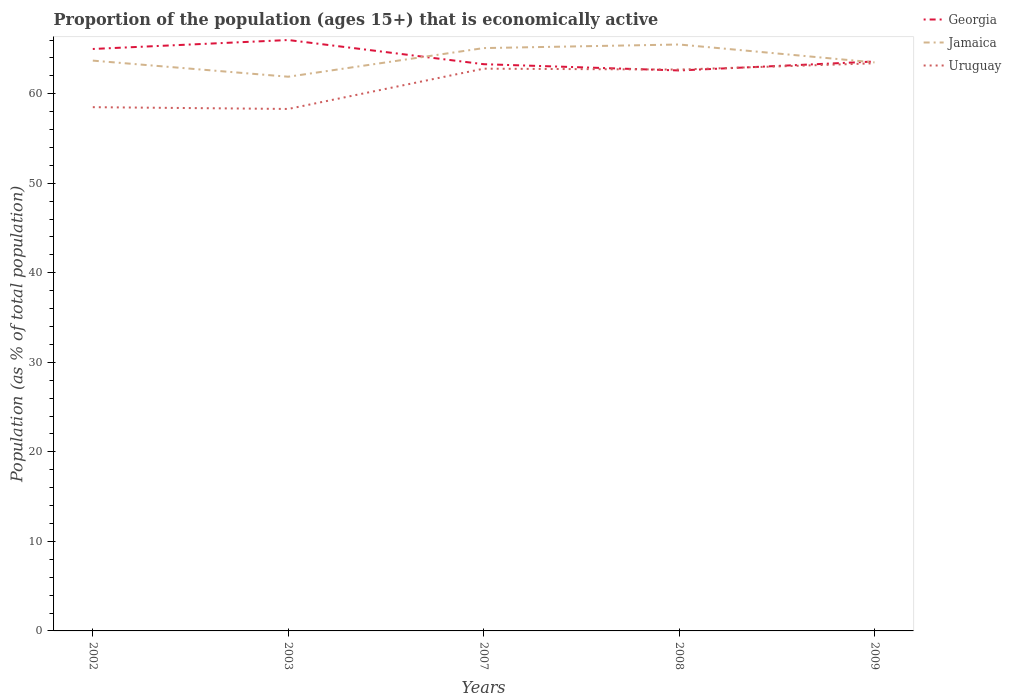Is the number of lines equal to the number of legend labels?
Ensure brevity in your answer.  Yes. Across all years, what is the maximum proportion of the population that is economically active in Uruguay?
Offer a very short reply. 58.3. What is the total proportion of the population that is economically active in Jamaica in the graph?
Provide a short and direct response. 1.6. What is the difference between the highest and the second highest proportion of the population that is economically active in Georgia?
Offer a very short reply. 3.4. What is the difference between the highest and the lowest proportion of the population that is economically active in Jamaica?
Give a very brief answer. 2. How many lines are there?
Offer a very short reply. 3. What is the difference between two consecutive major ticks on the Y-axis?
Offer a terse response. 10. Does the graph contain any zero values?
Ensure brevity in your answer.  No. Does the graph contain grids?
Keep it short and to the point. No. Where does the legend appear in the graph?
Your answer should be very brief. Top right. How are the legend labels stacked?
Give a very brief answer. Vertical. What is the title of the graph?
Offer a very short reply. Proportion of the population (ages 15+) that is economically active. Does "Greenland" appear as one of the legend labels in the graph?
Offer a terse response. No. What is the label or title of the Y-axis?
Your answer should be compact. Population (as % of total population). What is the Population (as % of total population) of Georgia in 2002?
Your answer should be very brief. 65. What is the Population (as % of total population) in Jamaica in 2002?
Your answer should be very brief. 63.7. What is the Population (as % of total population) in Uruguay in 2002?
Give a very brief answer. 58.5. What is the Population (as % of total population) in Georgia in 2003?
Keep it short and to the point. 66. What is the Population (as % of total population) in Jamaica in 2003?
Your answer should be compact. 61.9. What is the Population (as % of total population) of Uruguay in 2003?
Your response must be concise. 58.3. What is the Population (as % of total population) in Georgia in 2007?
Make the answer very short. 63.3. What is the Population (as % of total population) in Jamaica in 2007?
Offer a very short reply. 65.1. What is the Population (as % of total population) in Uruguay in 2007?
Keep it short and to the point. 62.8. What is the Population (as % of total population) of Georgia in 2008?
Provide a succinct answer. 62.6. What is the Population (as % of total population) in Jamaica in 2008?
Provide a succinct answer. 65.5. What is the Population (as % of total population) in Uruguay in 2008?
Ensure brevity in your answer.  62.7. What is the Population (as % of total population) of Georgia in 2009?
Ensure brevity in your answer.  63.6. What is the Population (as % of total population) of Jamaica in 2009?
Ensure brevity in your answer.  63.5. What is the Population (as % of total population) in Uruguay in 2009?
Keep it short and to the point. 63.4. Across all years, what is the maximum Population (as % of total population) in Georgia?
Keep it short and to the point. 66. Across all years, what is the maximum Population (as % of total population) of Jamaica?
Your response must be concise. 65.5. Across all years, what is the maximum Population (as % of total population) of Uruguay?
Give a very brief answer. 63.4. Across all years, what is the minimum Population (as % of total population) in Georgia?
Provide a short and direct response. 62.6. Across all years, what is the minimum Population (as % of total population) in Jamaica?
Provide a short and direct response. 61.9. Across all years, what is the minimum Population (as % of total population) in Uruguay?
Offer a very short reply. 58.3. What is the total Population (as % of total population) of Georgia in the graph?
Offer a very short reply. 320.5. What is the total Population (as % of total population) of Jamaica in the graph?
Ensure brevity in your answer.  319.7. What is the total Population (as % of total population) in Uruguay in the graph?
Give a very brief answer. 305.7. What is the difference between the Population (as % of total population) of Jamaica in 2002 and that in 2007?
Provide a succinct answer. -1.4. What is the difference between the Population (as % of total population) of Uruguay in 2002 and that in 2008?
Provide a short and direct response. -4.2. What is the difference between the Population (as % of total population) in Georgia in 2002 and that in 2009?
Provide a succinct answer. 1.4. What is the difference between the Population (as % of total population) of Jamaica in 2002 and that in 2009?
Your answer should be compact. 0.2. What is the difference between the Population (as % of total population) in Jamaica in 2003 and that in 2007?
Offer a very short reply. -3.2. What is the difference between the Population (as % of total population) in Uruguay in 2003 and that in 2007?
Make the answer very short. -4.5. What is the difference between the Population (as % of total population) in Jamaica in 2003 and that in 2008?
Make the answer very short. -3.6. What is the difference between the Population (as % of total population) of Uruguay in 2003 and that in 2008?
Offer a very short reply. -4.4. What is the difference between the Population (as % of total population) in Jamaica in 2003 and that in 2009?
Make the answer very short. -1.6. What is the difference between the Population (as % of total population) in Georgia in 2007 and that in 2008?
Your answer should be compact. 0.7. What is the difference between the Population (as % of total population) in Uruguay in 2007 and that in 2008?
Offer a terse response. 0.1. What is the difference between the Population (as % of total population) of Georgia in 2007 and that in 2009?
Offer a very short reply. -0.3. What is the difference between the Population (as % of total population) in Jamaica in 2007 and that in 2009?
Provide a succinct answer. 1.6. What is the difference between the Population (as % of total population) in Uruguay in 2007 and that in 2009?
Your answer should be compact. -0.6. What is the difference between the Population (as % of total population) in Georgia in 2008 and that in 2009?
Keep it short and to the point. -1. What is the difference between the Population (as % of total population) in Jamaica in 2008 and that in 2009?
Offer a terse response. 2. What is the difference between the Population (as % of total population) in Uruguay in 2008 and that in 2009?
Keep it short and to the point. -0.7. What is the difference between the Population (as % of total population) in Georgia in 2002 and the Population (as % of total population) in Jamaica in 2007?
Your response must be concise. -0.1. What is the difference between the Population (as % of total population) in Georgia in 2002 and the Population (as % of total population) in Uruguay in 2007?
Keep it short and to the point. 2.2. What is the difference between the Population (as % of total population) in Jamaica in 2002 and the Population (as % of total population) in Uruguay in 2007?
Give a very brief answer. 0.9. What is the difference between the Population (as % of total population) of Georgia in 2002 and the Population (as % of total population) of Jamaica in 2008?
Make the answer very short. -0.5. What is the difference between the Population (as % of total population) in Jamaica in 2002 and the Population (as % of total population) in Uruguay in 2008?
Give a very brief answer. 1. What is the difference between the Population (as % of total population) of Jamaica in 2002 and the Population (as % of total population) of Uruguay in 2009?
Offer a terse response. 0.3. What is the difference between the Population (as % of total population) in Georgia in 2003 and the Population (as % of total population) in Jamaica in 2008?
Make the answer very short. 0.5. What is the difference between the Population (as % of total population) in Georgia in 2007 and the Population (as % of total population) in Jamaica in 2008?
Provide a short and direct response. -2.2. What is the difference between the Population (as % of total population) in Jamaica in 2007 and the Population (as % of total population) in Uruguay in 2008?
Your answer should be very brief. 2.4. What is the difference between the Population (as % of total population) in Georgia in 2007 and the Population (as % of total population) in Jamaica in 2009?
Provide a short and direct response. -0.2. What is the difference between the Population (as % of total population) of Georgia in 2007 and the Population (as % of total population) of Uruguay in 2009?
Ensure brevity in your answer.  -0.1. What is the difference between the Population (as % of total population) of Jamaica in 2007 and the Population (as % of total population) of Uruguay in 2009?
Offer a terse response. 1.7. What is the difference between the Population (as % of total population) of Georgia in 2008 and the Population (as % of total population) of Jamaica in 2009?
Your response must be concise. -0.9. What is the difference between the Population (as % of total population) of Georgia in 2008 and the Population (as % of total population) of Uruguay in 2009?
Make the answer very short. -0.8. What is the difference between the Population (as % of total population) in Jamaica in 2008 and the Population (as % of total population) in Uruguay in 2009?
Your response must be concise. 2.1. What is the average Population (as % of total population) in Georgia per year?
Ensure brevity in your answer.  64.1. What is the average Population (as % of total population) of Jamaica per year?
Ensure brevity in your answer.  63.94. What is the average Population (as % of total population) in Uruguay per year?
Your response must be concise. 61.14. In the year 2003, what is the difference between the Population (as % of total population) in Georgia and Population (as % of total population) in Uruguay?
Keep it short and to the point. 7.7. In the year 2007, what is the difference between the Population (as % of total population) in Georgia and Population (as % of total population) in Uruguay?
Your answer should be very brief. 0.5. In the year 2008, what is the difference between the Population (as % of total population) of Georgia and Population (as % of total population) of Uruguay?
Ensure brevity in your answer.  -0.1. In the year 2009, what is the difference between the Population (as % of total population) of Georgia and Population (as % of total population) of Jamaica?
Your response must be concise. 0.1. In the year 2009, what is the difference between the Population (as % of total population) of Georgia and Population (as % of total population) of Uruguay?
Provide a short and direct response. 0.2. In the year 2009, what is the difference between the Population (as % of total population) of Jamaica and Population (as % of total population) of Uruguay?
Your answer should be very brief. 0.1. What is the ratio of the Population (as % of total population) of Jamaica in 2002 to that in 2003?
Offer a terse response. 1.03. What is the ratio of the Population (as % of total population) in Uruguay in 2002 to that in 2003?
Your response must be concise. 1. What is the ratio of the Population (as % of total population) of Georgia in 2002 to that in 2007?
Your answer should be compact. 1.03. What is the ratio of the Population (as % of total population) in Jamaica in 2002 to that in 2007?
Provide a short and direct response. 0.98. What is the ratio of the Population (as % of total population) of Uruguay in 2002 to that in 2007?
Give a very brief answer. 0.93. What is the ratio of the Population (as % of total population) of Georgia in 2002 to that in 2008?
Provide a succinct answer. 1.04. What is the ratio of the Population (as % of total population) of Jamaica in 2002 to that in 2008?
Keep it short and to the point. 0.97. What is the ratio of the Population (as % of total population) in Uruguay in 2002 to that in 2008?
Offer a terse response. 0.93. What is the ratio of the Population (as % of total population) of Uruguay in 2002 to that in 2009?
Offer a very short reply. 0.92. What is the ratio of the Population (as % of total population) of Georgia in 2003 to that in 2007?
Make the answer very short. 1.04. What is the ratio of the Population (as % of total population) in Jamaica in 2003 to that in 2007?
Your response must be concise. 0.95. What is the ratio of the Population (as % of total population) of Uruguay in 2003 to that in 2007?
Your response must be concise. 0.93. What is the ratio of the Population (as % of total population) of Georgia in 2003 to that in 2008?
Keep it short and to the point. 1.05. What is the ratio of the Population (as % of total population) of Jamaica in 2003 to that in 2008?
Offer a very short reply. 0.94. What is the ratio of the Population (as % of total population) in Uruguay in 2003 to that in 2008?
Give a very brief answer. 0.93. What is the ratio of the Population (as % of total population) in Georgia in 2003 to that in 2009?
Provide a succinct answer. 1.04. What is the ratio of the Population (as % of total population) of Jamaica in 2003 to that in 2009?
Ensure brevity in your answer.  0.97. What is the ratio of the Population (as % of total population) of Uruguay in 2003 to that in 2009?
Your response must be concise. 0.92. What is the ratio of the Population (as % of total population) in Georgia in 2007 to that in 2008?
Offer a very short reply. 1.01. What is the ratio of the Population (as % of total population) in Uruguay in 2007 to that in 2008?
Your answer should be very brief. 1. What is the ratio of the Population (as % of total population) in Jamaica in 2007 to that in 2009?
Make the answer very short. 1.03. What is the ratio of the Population (as % of total population) in Georgia in 2008 to that in 2009?
Provide a short and direct response. 0.98. What is the ratio of the Population (as % of total population) of Jamaica in 2008 to that in 2009?
Your response must be concise. 1.03. What is the difference between the highest and the second highest Population (as % of total population) in Georgia?
Offer a terse response. 1. What is the difference between the highest and the second highest Population (as % of total population) of Uruguay?
Ensure brevity in your answer.  0.6. What is the difference between the highest and the lowest Population (as % of total population) in Jamaica?
Your response must be concise. 3.6. What is the difference between the highest and the lowest Population (as % of total population) of Uruguay?
Ensure brevity in your answer.  5.1. 